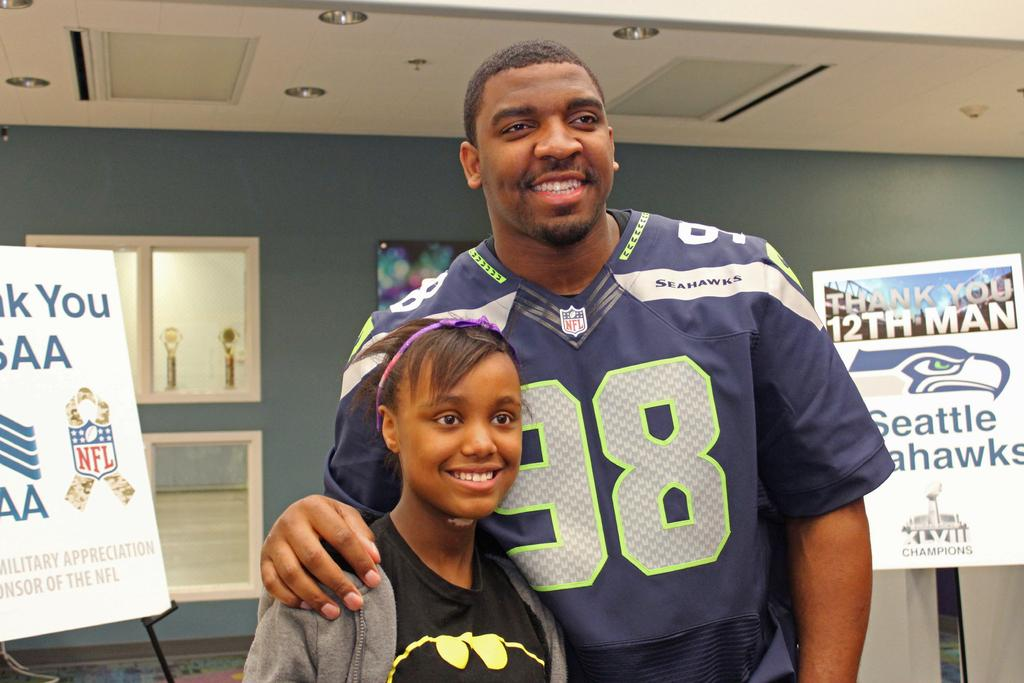<image>
Offer a succinct explanation of the picture presented. A man posing with a young girl with the man that says 98 